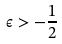<formula> <loc_0><loc_0><loc_500><loc_500>\epsilon > - \frac { 1 } { 2 }</formula> 